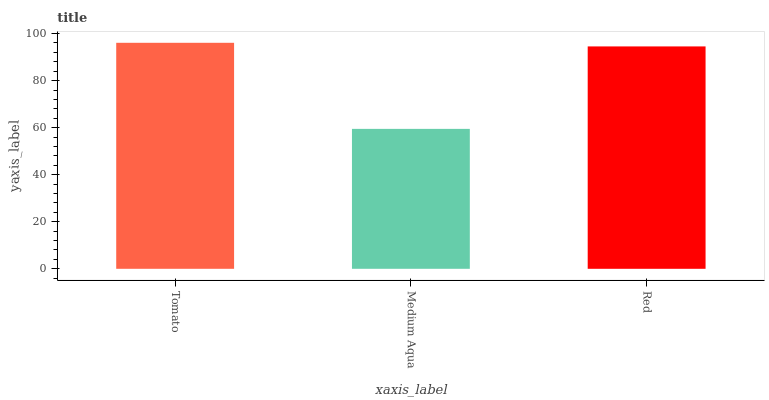Is Medium Aqua the minimum?
Answer yes or no. Yes. Is Tomato the maximum?
Answer yes or no. Yes. Is Red the minimum?
Answer yes or no. No. Is Red the maximum?
Answer yes or no. No. Is Red greater than Medium Aqua?
Answer yes or no. Yes. Is Medium Aqua less than Red?
Answer yes or no. Yes. Is Medium Aqua greater than Red?
Answer yes or no. No. Is Red less than Medium Aqua?
Answer yes or no. No. Is Red the high median?
Answer yes or no. Yes. Is Red the low median?
Answer yes or no. Yes. Is Tomato the high median?
Answer yes or no. No. Is Tomato the low median?
Answer yes or no. No. 